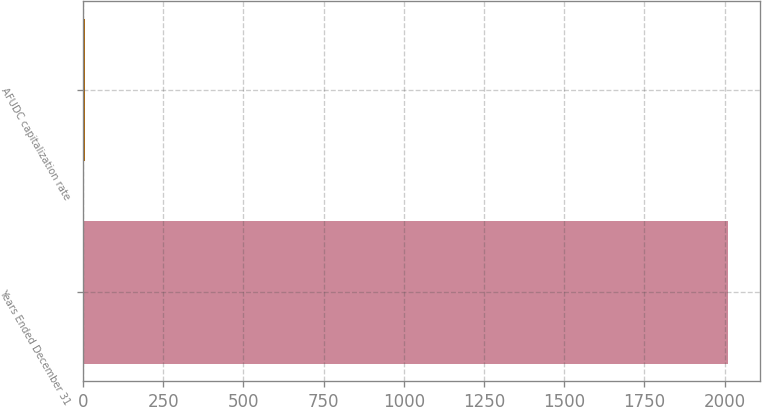Convert chart. <chart><loc_0><loc_0><loc_500><loc_500><bar_chart><fcel>Years Ended December 31<fcel>AFUDC capitalization rate<nl><fcel>2010<fcel>7.6<nl></chart> 